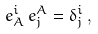<formula> <loc_0><loc_0><loc_500><loc_500>e _ { A } ^ { i } \, e ^ { A } _ { j } = \delta _ { j } ^ { i } \, ,</formula> 